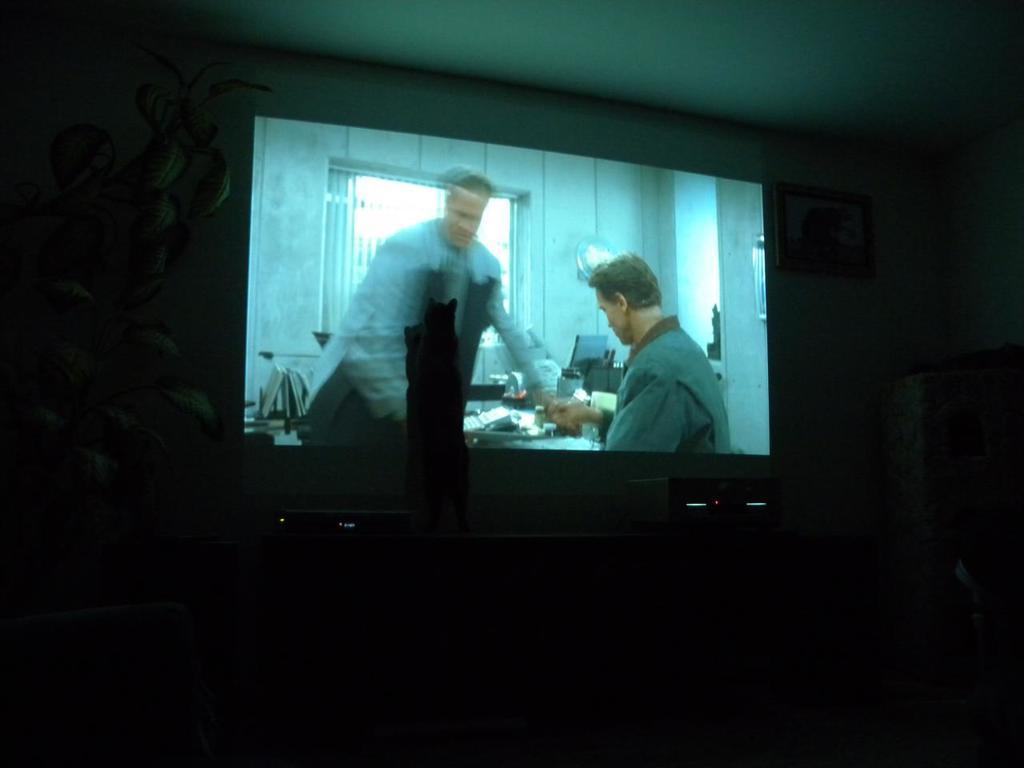Describe this image in one or two sentences. In this picture I can see a display screen and a plant on the left side and looks like a photo frame on the wall and a cupboard on the right side. 